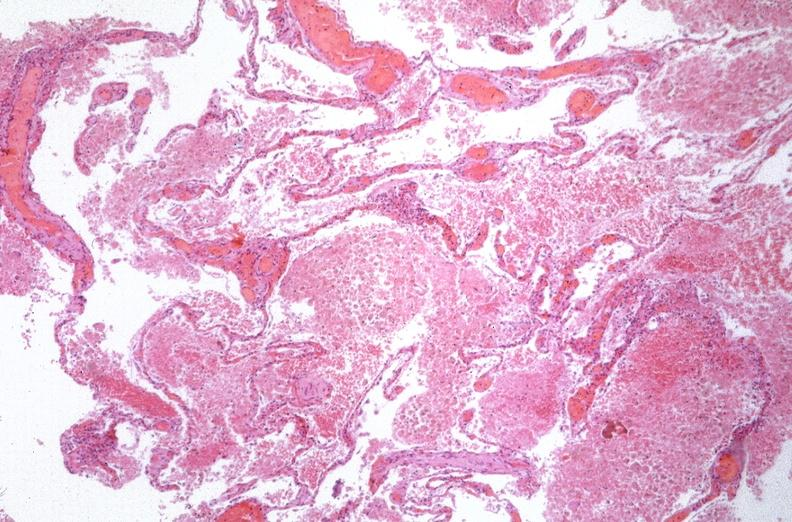s supernumerary digit present?
Answer the question using a single word or phrase. No 